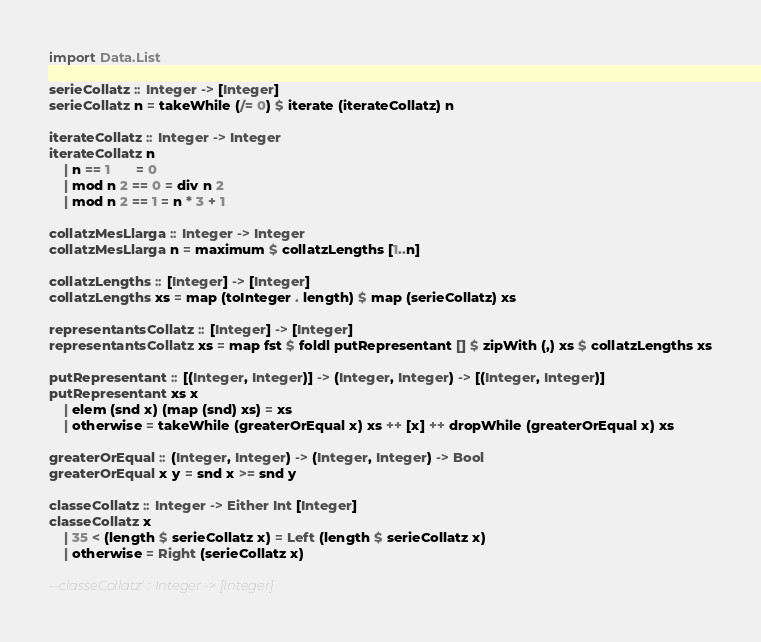Convert code to text. <code><loc_0><loc_0><loc_500><loc_500><_Haskell_>import Data.List

serieCollatz :: Integer -> [Integer]
serieCollatz n = takeWhile (/= 0) $ iterate (iterateCollatz) n

iterateCollatz :: Integer -> Integer
iterateCollatz n
    | n == 1       = 0
    | mod n 2 == 0 = div n 2
    | mod n 2 == 1 = n * 3 + 1

collatzMesLlarga :: Integer -> Integer
collatzMesLlarga n = maximum $ collatzLengths [1..n]

collatzLengths :: [Integer] -> [Integer]
collatzLengths xs = map (toInteger . length) $ map (serieCollatz) xs

representantsCollatz :: [Integer] -> [Integer]
representantsCollatz xs = map fst $ foldl putRepresentant [] $ zipWith (,) xs $ collatzLengths xs

putRepresentant :: [(Integer, Integer)] -> (Integer, Integer) -> [(Integer, Integer)]
putRepresentant xs x
    | elem (snd x) (map (snd) xs) = xs
    | otherwise = takeWhile (greaterOrEqual x) xs ++ [x] ++ dropWhile (greaterOrEqual x) xs

greaterOrEqual :: (Integer, Integer) -> (Integer, Integer) -> Bool
greaterOrEqual x y = snd x >= snd y

classeCollatz :: Integer -> Either Int [Integer]
classeCollatz x
    | 35 < (length $ serieCollatz x) = Left (length $ serieCollatz x)
    | otherwise = Right (serieCollatz x)

--classeCollatz' :: Integer -> [Integer]
</code> 